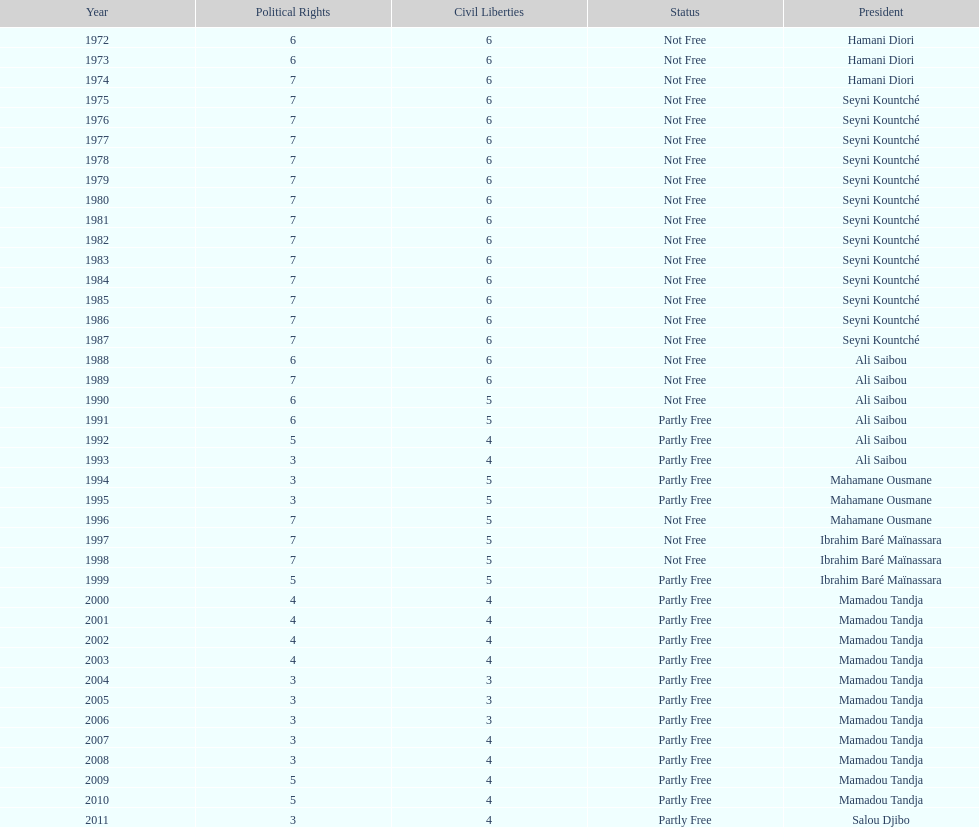Who ruled longer, ali saibou or mamadou tandja? Mamadou Tandja. 